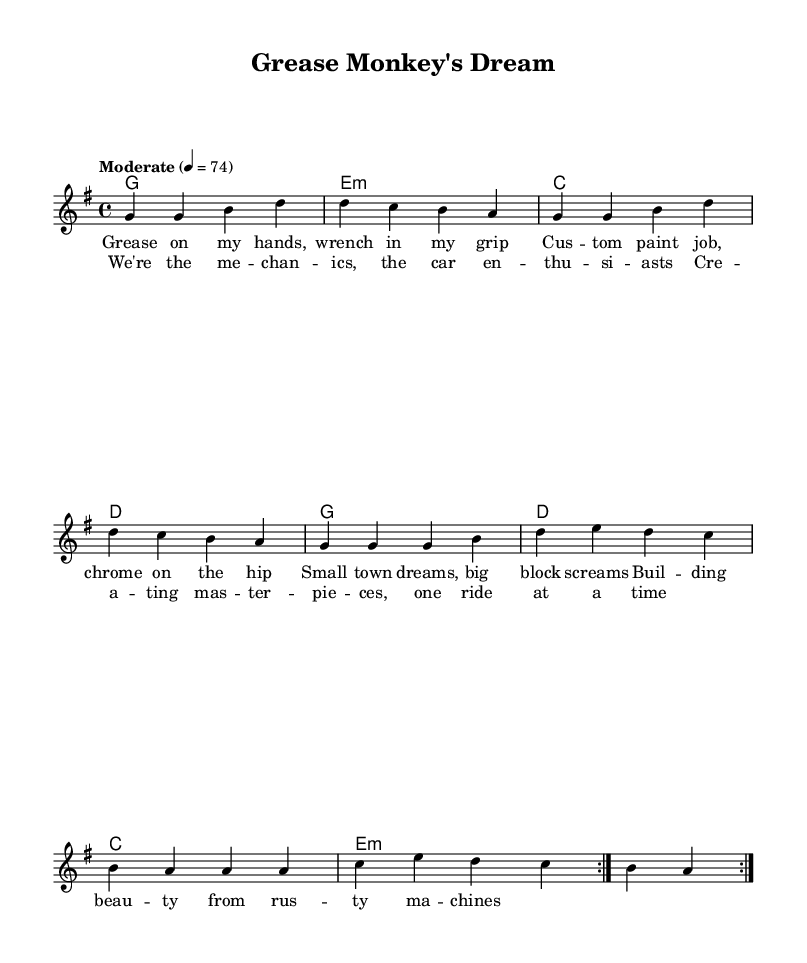What is the key signature of this music? The key signature is indicated at the beginning of the score. It shows one sharp (F#), which corresponds to D major or B minor, but since the overall context of the piece leans towards a more rock feel, it would be considered G major as stated in the header.
Answer: G major What is the time signature of this music? The time signature appears at the start of the score and is denoted by the numbers above the staff. It shows "4/4," which indicates four beats per measure and is a common time signature in rock music.
Answer: 4/4 What is the tempo marking for this music? The tempo is noted at the beginning of the score in the tempo text; it states "Moderate" followed by the beats per minute (74), indicating how fast the piece should be played.
Answer: Moderate 74 What lyrical theme is presented in the chorus? The lyrics of the chorus describe the pride and creativity of mechanics and car enthusiasts, emphasizing craftsmanship and the creation of "masterpieces." This theme is a celebration of this small-town culture involving cars.
Answer: Mechanics and enthusiasm What chord is used in the second measure of the harmony? The harmony section indicates the chord changes aligned above the corresponding measures. In the second measure, the chord is "e minor," which can be inferred directly from its notation.
Answer: E minor What is the overall structure of the song based on the provided information? The song structure can be determined from the "repeat volta" notation at the beginning of the melody, which shows that the section will repeat, typically suggesting a verse-chorus format which is common in rock music. The first section appears to be a verse followed by a chorus, and this sequence is indicated by the repeated notations.
Answer: Verse-Chorus 